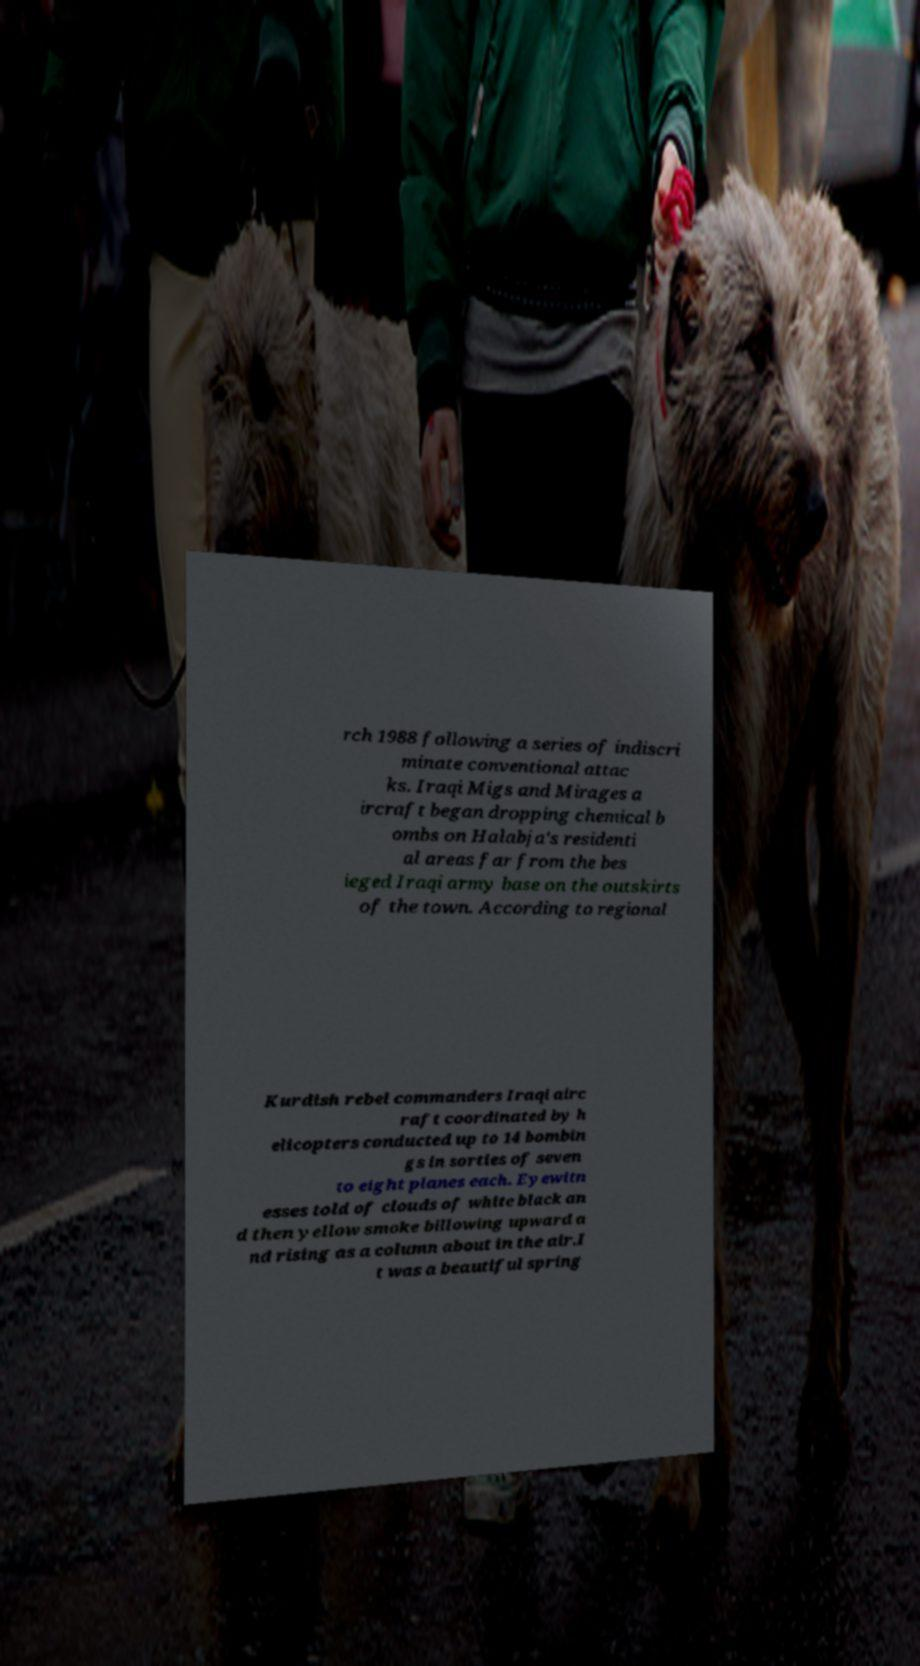There's text embedded in this image that I need extracted. Can you transcribe it verbatim? rch 1988 following a series of indiscri minate conventional attac ks. Iraqi Migs and Mirages a ircraft began dropping chemical b ombs on Halabja's residenti al areas far from the bes ieged Iraqi army base on the outskirts of the town. According to regional Kurdish rebel commanders Iraqi airc raft coordinated by h elicopters conducted up to 14 bombin gs in sorties of seven to eight planes each. Eyewitn esses told of clouds of white black an d then yellow smoke billowing upward a nd rising as a column about in the air.I t was a beautiful spring 